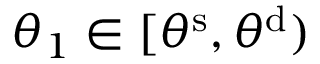<formula> <loc_0><loc_0><loc_500><loc_500>\theta _ { 1 } \in [ \theta ^ { s } , \theta ^ { d } )</formula> 